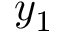<formula> <loc_0><loc_0><loc_500><loc_500>y _ { 1 }</formula> 